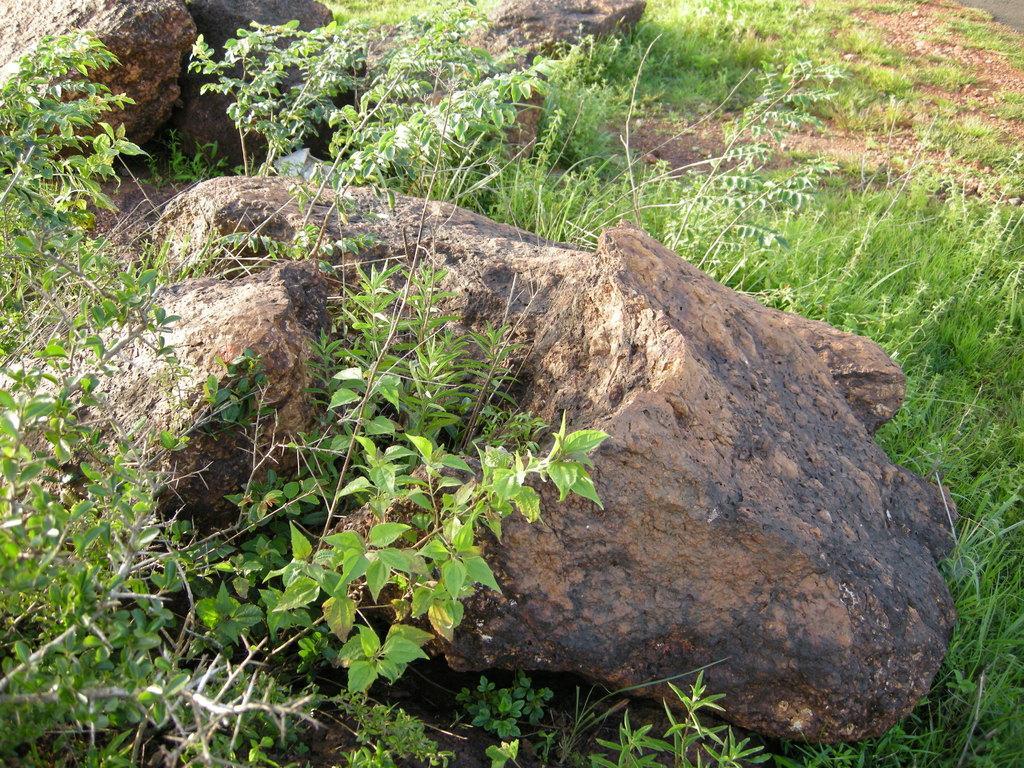Could you give a brief overview of what you see in this image? In this image we can see some rocks, plants, grass and some other objects. 